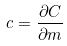Convert formula to latex. <formula><loc_0><loc_0><loc_500><loc_500>c = \frac { \partial C } { \partial m }</formula> 